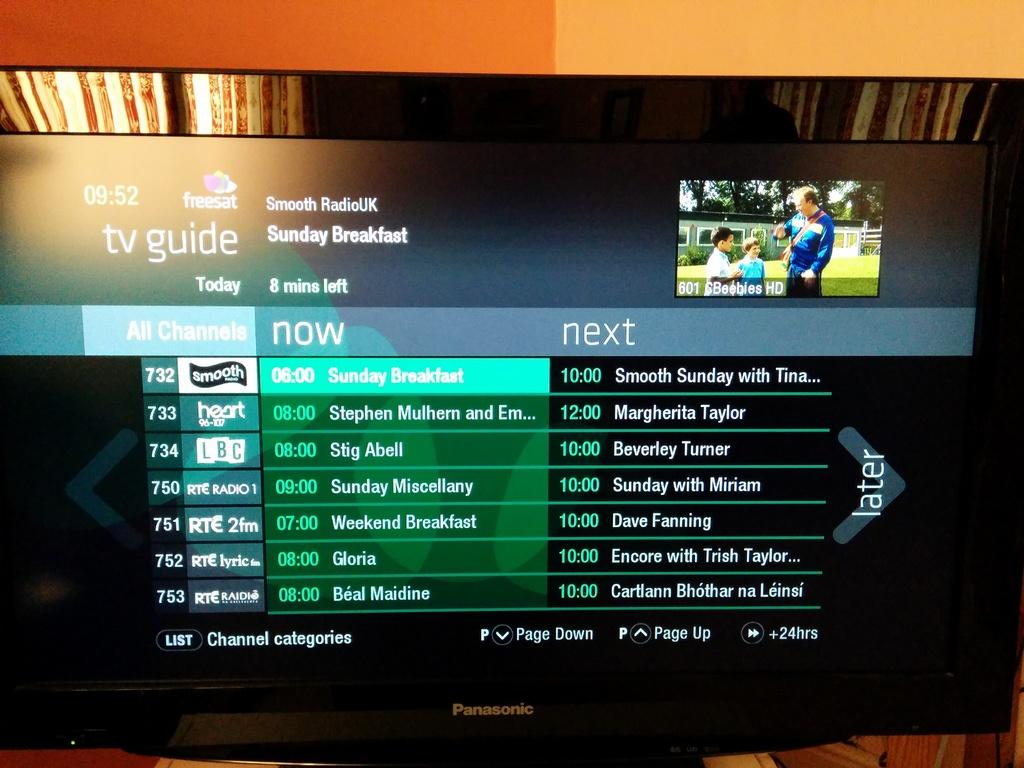<image>
Create a compact narrative representing the image presented. TV screen which says TV Guide on the top. 